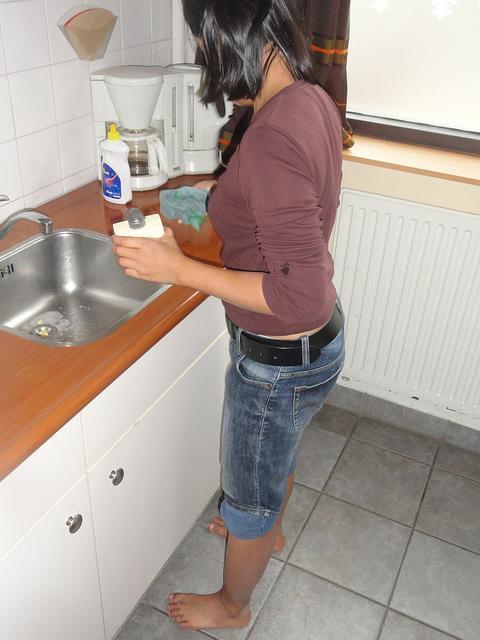What is this room most likely called?
Select the accurate answer and provide justification: `Answer: choice
Rationale: srationale.`
Options: Dining room, family room, utility room, bedroom. Answer: utility room.
Rationale: This room is for people to do quick tasks with since it's so small. 